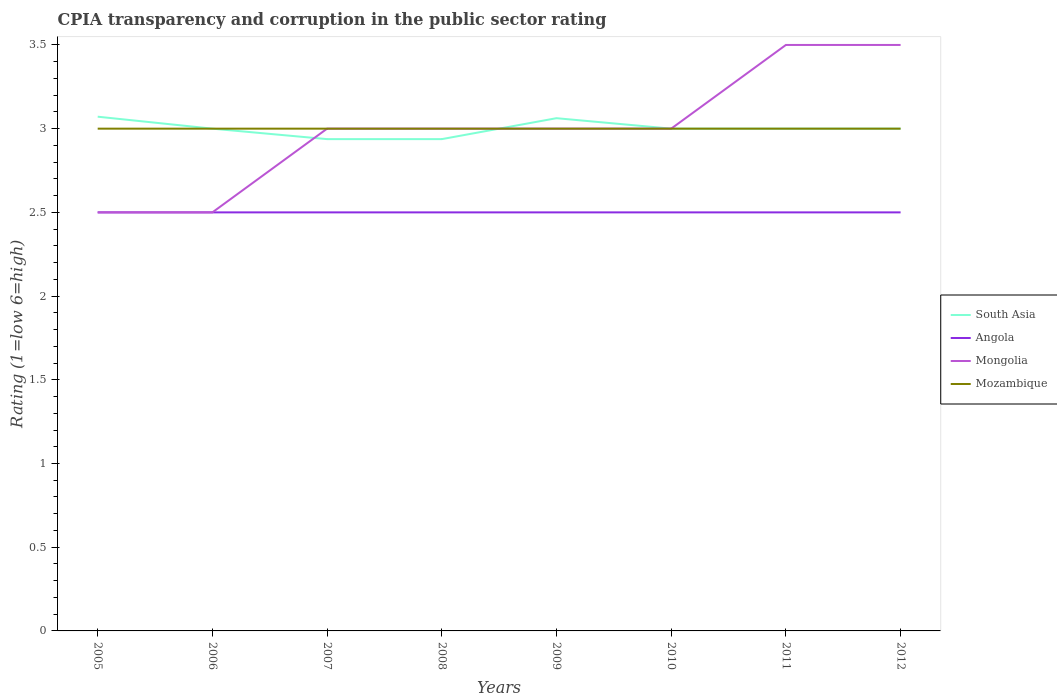How many different coloured lines are there?
Provide a short and direct response. 4. Does the line corresponding to Mongolia intersect with the line corresponding to South Asia?
Offer a very short reply. Yes. Across all years, what is the maximum CPIA rating in Angola?
Your answer should be very brief. 2.5. In which year was the CPIA rating in Angola maximum?
Offer a very short reply. 2005. What is the total CPIA rating in Angola in the graph?
Provide a short and direct response. 0. What is the difference between the highest and the lowest CPIA rating in Mongolia?
Your answer should be very brief. 2. How many years are there in the graph?
Give a very brief answer. 8. Are the values on the major ticks of Y-axis written in scientific E-notation?
Your response must be concise. No. Does the graph contain grids?
Your answer should be very brief. No. Where does the legend appear in the graph?
Provide a short and direct response. Center right. How are the legend labels stacked?
Keep it short and to the point. Vertical. What is the title of the graph?
Offer a very short reply. CPIA transparency and corruption in the public sector rating. Does "Czech Republic" appear as one of the legend labels in the graph?
Provide a short and direct response. No. What is the label or title of the X-axis?
Your answer should be compact. Years. What is the label or title of the Y-axis?
Offer a terse response. Rating (1=low 6=high). What is the Rating (1=low 6=high) in South Asia in 2005?
Keep it short and to the point. 3.07. What is the Rating (1=low 6=high) of Angola in 2005?
Keep it short and to the point. 2.5. What is the Rating (1=low 6=high) in Mozambique in 2005?
Your response must be concise. 3. What is the Rating (1=low 6=high) in South Asia in 2006?
Your answer should be very brief. 3. What is the Rating (1=low 6=high) in Angola in 2006?
Provide a succinct answer. 2.5. What is the Rating (1=low 6=high) of South Asia in 2007?
Keep it short and to the point. 2.94. What is the Rating (1=low 6=high) in Angola in 2007?
Give a very brief answer. 2.5. What is the Rating (1=low 6=high) of Mongolia in 2007?
Keep it short and to the point. 3. What is the Rating (1=low 6=high) of South Asia in 2008?
Provide a short and direct response. 2.94. What is the Rating (1=low 6=high) of Angola in 2008?
Give a very brief answer. 2.5. What is the Rating (1=low 6=high) in South Asia in 2009?
Ensure brevity in your answer.  3.06. What is the Rating (1=low 6=high) in Angola in 2009?
Your answer should be compact. 2.5. What is the Rating (1=low 6=high) in Mongolia in 2009?
Offer a very short reply. 3. What is the Rating (1=low 6=high) in Mongolia in 2011?
Your answer should be very brief. 3.5. What is the Rating (1=low 6=high) in Mozambique in 2011?
Keep it short and to the point. 3. What is the Rating (1=low 6=high) in South Asia in 2012?
Make the answer very short. 3. What is the Rating (1=low 6=high) in Angola in 2012?
Give a very brief answer. 2.5. What is the Rating (1=low 6=high) in Mongolia in 2012?
Your response must be concise. 3.5. Across all years, what is the maximum Rating (1=low 6=high) in South Asia?
Make the answer very short. 3.07. Across all years, what is the maximum Rating (1=low 6=high) in Angola?
Provide a short and direct response. 2.5. Across all years, what is the minimum Rating (1=low 6=high) of South Asia?
Your answer should be very brief. 2.94. Across all years, what is the minimum Rating (1=low 6=high) of Mozambique?
Your response must be concise. 3. What is the total Rating (1=low 6=high) in South Asia in the graph?
Give a very brief answer. 24.01. What is the difference between the Rating (1=low 6=high) in South Asia in 2005 and that in 2006?
Provide a succinct answer. 0.07. What is the difference between the Rating (1=low 6=high) of South Asia in 2005 and that in 2007?
Offer a very short reply. 0.13. What is the difference between the Rating (1=low 6=high) in Angola in 2005 and that in 2007?
Keep it short and to the point. 0. What is the difference between the Rating (1=low 6=high) in South Asia in 2005 and that in 2008?
Offer a terse response. 0.13. What is the difference between the Rating (1=low 6=high) of Angola in 2005 and that in 2008?
Provide a short and direct response. 0. What is the difference between the Rating (1=low 6=high) of Mongolia in 2005 and that in 2008?
Your answer should be compact. -0.5. What is the difference between the Rating (1=low 6=high) in Mozambique in 2005 and that in 2008?
Keep it short and to the point. 0. What is the difference between the Rating (1=low 6=high) of South Asia in 2005 and that in 2009?
Keep it short and to the point. 0.01. What is the difference between the Rating (1=low 6=high) in Angola in 2005 and that in 2009?
Your answer should be compact. 0. What is the difference between the Rating (1=low 6=high) in South Asia in 2005 and that in 2010?
Keep it short and to the point. 0.07. What is the difference between the Rating (1=low 6=high) in Mongolia in 2005 and that in 2010?
Make the answer very short. -0.5. What is the difference between the Rating (1=low 6=high) of Mozambique in 2005 and that in 2010?
Ensure brevity in your answer.  0. What is the difference between the Rating (1=low 6=high) of South Asia in 2005 and that in 2011?
Ensure brevity in your answer.  0.07. What is the difference between the Rating (1=low 6=high) in Angola in 2005 and that in 2011?
Ensure brevity in your answer.  0. What is the difference between the Rating (1=low 6=high) of South Asia in 2005 and that in 2012?
Keep it short and to the point. 0.07. What is the difference between the Rating (1=low 6=high) of Angola in 2005 and that in 2012?
Provide a short and direct response. 0. What is the difference between the Rating (1=low 6=high) in Mongolia in 2005 and that in 2012?
Keep it short and to the point. -1. What is the difference between the Rating (1=low 6=high) in Mozambique in 2005 and that in 2012?
Give a very brief answer. 0. What is the difference between the Rating (1=low 6=high) of South Asia in 2006 and that in 2007?
Offer a terse response. 0.06. What is the difference between the Rating (1=low 6=high) in Mongolia in 2006 and that in 2007?
Offer a very short reply. -0.5. What is the difference between the Rating (1=low 6=high) of Mozambique in 2006 and that in 2007?
Give a very brief answer. 0. What is the difference between the Rating (1=low 6=high) in South Asia in 2006 and that in 2008?
Your response must be concise. 0.06. What is the difference between the Rating (1=low 6=high) in Angola in 2006 and that in 2008?
Keep it short and to the point. 0. What is the difference between the Rating (1=low 6=high) in Mongolia in 2006 and that in 2008?
Offer a terse response. -0.5. What is the difference between the Rating (1=low 6=high) in Mozambique in 2006 and that in 2008?
Provide a succinct answer. 0. What is the difference between the Rating (1=low 6=high) of South Asia in 2006 and that in 2009?
Provide a succinct answer. -0.06. What is the difference between the Rating (1=low 6=high) in Mozambique in 2006 and that in 2009?
Offer a very short reply. 0. What is the difference between the Rating (1=low 6=high) of South Asia in 2006 and that in 2010?
Give a very brief answer. 0. What is the difference between the Rating (1=low 6=high) of Angola in 2006 and that in 2010?
Provide a short and direct response. 0. What is the difference between the Rating (1=low 6=high) of Mozambique in 2006 and that in 2010?
Offer a very short reply. 0. What is the difference between the Rating (1=low 6=high) of Angola in 2006 and that in 2011?
Provide a short and direct response. 0. What is the difference between the Rating (1=low 6=high) of Mongolia in 2006 and that in 2011?
Provide a succinct answer. -1. What is the difference between the Rating (1=low 6=high) in South Asia in 2007 and that in 2008?
Your answer should be compact. 0. What is the difference between the Rating (1=low 6=high) in South Asia in 2007 and that in 2009?
Keep it short and to the point. -0.12. What is the difference between the Rating (1=low 6=high) in Mozambique in 2007 and that in 2009?
Give a very brief answer. 0. What is the difference between the Rating (1=low 6=high) in South Asia in 2007 and that in 2010?
Ensure brevity in your answer.  -0.06. What is the difference between the Rating (1=low 6=high) of Angola in 2007 and that in 2010?
Ensure brevity in your answer.  0. What is the difference between the Rating (1=low 6=high) in Mongolia in 2007 and that in 2010?
Give a very brief answer. 0. What is the difference between the Rating (1=low 6=high) of South Asia in 2007 and that in 2011?
Offer a very short reply. -0.06. What is the difference between the Rating (1=low 6=high) in South Asia in 2007 and that in 2012?
Provide a succinct answer. -0.06. What is the difference between the Rating (1=low 6=high) in Mongolia in 2007 and that in 2012?
Your answer should be very brief. -0.5. What is the difference between the Rating (1=low 6=high) of South Asia in 2008 and that in 2009?
Offer a very short reply. -0.12. What is the difference between the Rating (1=low 6=high) in Angola in 2008 and that in 2009?
Your answer should be very brief. 0. What is the difference between the Rating (1=low 6=high) in Mozambique in 2008 and that in 2009?
Offer a very short reply. 0. What is the difference between the Rating (1=low 6=high) in South Asia in 2008 and that in 2010?
Make the answer very short. -0.06. What is the difference between the Rating (1=low 6=high) in Angola in 2008 and that in 2010?
Provide a succinct answer. 0. What is the difference between the Rating (1=low 6=high) in Mongolia in 2008 and that in 2010?
Make the answer very short. 0. What is the difference between the Rating (1=low 6=high) in South Asia in 2008 and that in 2011?
Ensure brevity in your answer.  -0.06. What is the difference between the Rating (1=low 6=high) in Mongolia in 2008 and that in 2011?
Your answer should be very brief. -0.5. What is the difference between the Rating (1=low 6=high) in Mozambique in 2008 and that in 2011?
Give a very brief answer. 0. What is the difference between the Rating (1=low 6=high) in South Asia in 2008 and that in 2012?
Your answer should be compact. -0.06. What is the difference between the Rating (1=low 6=high) in Mozambique in 2008 and that in 2012?
Make the answer very short. 0. What is the difference between the Rating (1=low 6=high) in South Asia in 2009 and that in 2010?
Offer a very short reply. 0.06. What is the difference between the Rating (1=low 6=high) in Angola in 2009 and that in 2010?
Your answer should be very brief. 0. What is the difference between the Rating (1=low 6=high) in Mozambique in 2009 and that in 2010?
Offer a terse response. 0. What is the difference between the Rating (1=low 6=high) of South Asia in 2009 and that in 2011?
Offer a very short reply. 0.06. What is the difference between the Rating (1=low 6=high) in South Asia in 2009 and that in 2012?
Your response must be concise. 0.06. What is the difference between the Rating (1=low 6=high) in Angola in 2009 and that in 2012?
Your response must be concise. 0. What is the difference between the Rating (1=low 6=high) in Mongolia in 2009 and that in 2012?
Your response must be concise. -0.5. What is the difference between the Rating (1=low 6=high) in Mozambique in 2009 and that in 2012?
Provide a short and direct response. 0. What is the difference between the Rating (1=low 6=high) in Angola in 2010 and that in 2011?
Offer a very short reply. 0. What is the difference between the Rating (1=low 6=high) in South Asia in 2011 and that in 2012?
Make the answer very short. 0. What is the difference between the Rating (1=low 6=high) of South Asia in 2005 and the Rating (1=low 6=high) of Angola in 2006?
Make the answer very short. 0.57. What is the difference between the Rating (1=low 6=high) in South Asia in 2005 and the Rating (1=low 6=high) in Mozambique in 2006?
Make the answer very short. 0.07. What is the difference between the Rating (1=low 6=high) in Angola in 2005 and the Rating (1=low 6=high) in Mozambique in 2006?
Make the answer very short. -0.5. What is the difference between the Rating (1=low 6=high) of South Asia in 2005 and the Rating (1=low 6=high) of Mongolia in 2007?
Offer a terse response. 0.07. What is the difference between the Rating (1=low 6=high) in South Asia in 2005 and the Rating (1=low 6=high) in Mozambique in 2007?
Keep it short and to the point. 0.07. What is the difference between the Rating (1=low 6=high) in Angola in 2005 and the Rating (1=low 6=high) in Mongolia in 2007?
Ensure brevity in your answer.  -0.5. What is the difference between the Rating (1=low 6=high) in Angola in 2005 and the Rating (1=low 6=high) in Mozambique in 2007?
Ensure brevity in your answer.  -0.5. What is the difference between the Rating (1=low 6=high) in South Asia in 2005 and the Rating (1=low 6=high) in Mongolia in 2008?
Give a very brief answer. 0.07. What is the difference between the Rating (1=low 6=high) in South Asia in 2005 and the Rating (1=low 6=high) in Mozambique in 2008?
Offer a terse response. 0.07. What is the difference between the Rating (1=low 6=high) of South Asia in 2005 and the Rating (1=low 6=high) of Mongolia in 2009?
Provide a succinct answer. 0.07. What is the difference between the Rating (1=low 6=high) of South Asia in 2005 and the Rating (1=low 6=high) of Mozambique in 2009?
Keep it short and to the point. 0.07. What is the difference between the Rating (1=low 6=high) in South Asia in 2005 and the Rating (1=low 6=high) in Mongolia in 2010?
Give a very brief answer. 0.07. What is the difference between the Rating (1=low 6=high) in South Asia in 2005 and the Rating (1=low 6=high) in Mozambique in 2010?
Ensure brevity in your answer.  0.07. What is the difference between the Rating (1=low 6=high) in Angola in 2005 and the Rating (1=low 6=high) in Mozambique in 2010?
Offer a terse response. -0.5. What is the difference between the Rating (1=low 6=high) of Mongolia in 2005 and the Rating (1=low 6=high) of Mozambique in 2010?
Your response must be concise. -0.5. What is the difference between the Rating (1=low 6=high) of South Asia in 2005 and the Rating (1=low 6=high) of Mongolia in 2011?
Ensure brevity in your answer.  -0.43. What is the difference between the Rating (1=low 6=high) in South Asia in 2005 and the Rating (1=low 6=high) in Mozambique in 2011?
Ensure brevity in your answer.  0.07. What is the difference between the Rating (1=low 6=high) of Angola in 2005 and the Rating (1=low 6=high) of Mozambique in 2011?
Make the answer very short. -0.5. What is the difference between the Rating (1=low 6=high) of South Asia in 2005 and the Rating (1=low 6=high) of Mongolia in 2012?
Provide a succinct answer. -0.43. What is the difference between the Rating (1=low 6=high) of South Asia in 2005 and the Rating (1=low 6=high) of Mozambique in 2012?
Your answer should be compact. 0.07. What is the difference between the Rating (1=low 6=high) in Angola in 2005 and the Rating (1=low 6=high) in Mongolia in 2012?
Offer a very short reply. -1. What is the difference between the Rating (1=low 6=high) in Angola in 2005 and the Rating (1=low 6=high) in Mozambique in 2012?
Your response must be concise. -0.5. What is the difference between the Rating (1=low 6=high) of South Asia in 2006 and the Rating (1=low 6=high) of Angola in 2007?
Provide a short and direct response. 0.5. What is the difference between the Rating (1=low 6=high) in South Asia in 2006 and the Rating (1=low 6=high) in Mongolia in 2007?
Give a very brief answer. 0. What is the difference between the Rating (1=low 6=high) in Angola in 2006 and the Rating (1=low 6=high) in Mongolia in 2007?
Provide a succinct answer. -0.5. What is the difference between the Rating (1=low 6=high) in South Asia in 2006 and the Rating (1=low 6=high) in Angola in 2008?
Your answer should be very brief. 0.5. What is the difference between the Rating (1=low 6=high) in Mongolia in 2006 and the Rating (1=low 6=high) in Mozambique in 2008?
Provide a succinct answer. -0.5. What is the difference between the Rating (1=low 6=high) of Angola in 2006 and the Rating (1=low 6=high) of Mongolia in 2009?
Provide a short and direct response. -0.5. What is the difference between the Rating (1=low 6=high) in Mongolia in 2006 and the Rating (1=low 6=high) in Mozambique in 2009?
Your response must be concise. -0.5. What is the difference between the Rating (1=low 6=high) of Angola in 2006 and the Rating (1=low 6=high) of Mozambique in 2010?
Give a very brief answer. -0.5. What is the difference between the Rating (1=low 6=high) in Mongolia in 2006 and the Rating (1=low 6=high) in Mozambique in 2010?
Offer a very short reply. -0.5. What is the difference between the Rating (1=low 6=high) of South Asia in 2006 and the Rating (1=low 6=high) of Angola in 2011?
Give a very brief answer. 0.5. What is the difference between the Rating (1=low 6=high) in South Asia in 2006 and the Rating (1=low 6=high) in Mongolia in 2011?
Your answer should be compact. -0.5. What is the difference between the Rating (1=low 6=high) in South Asia in 2006 and the Rating (1=low 6=high) in Mozambique in 2011?
Provide a succinct answer. 0. What is the difference between the Rating (1=low 6=high) of Angola in 2006 and the Rating (1=low 6=high) of Mozambique in 2011?
Offer a very short reply. -0.5. What is the difference between the Rating (1=low 6=high) in Mongolia in 2006 and the Rating (1=low 6=high) in Mozambique in 2011?
Give a very brief answer. -0.5. What is the difference between the Rating (1=low 6=high) of South Asia in 2006 and the Rating (1=low 6=high) of Angola in 2012?
Make the answer very short. 0.5. What is the difference between the Rating (1=low 6=high) in South Asia in 2006 and the Rating (1=low 6=high) in Mongolia in 2012?
Give a very brief answer. -0.5. What is the difference between the Rating (1=low 6=high) of Angola in 2006 and the Rating (1=low 6=high) of Mongolia in 2012?
Provide a short and direct response. -1. What is the difference between the Rating (1=low 6=high) in Mongolia in 2006 and the Rating (1=low 6=high) in Mozambique in 2012?
Keep it short and to the point. -0.5. What is the difference between the Rating (1=low 6=high) of South Asia in 2007 and the Rating (1=low 6=high) of Angola in 2008?
Offer a terse response. 0.44. What is the difference between the Rating (1=low 6=high) of South Asia in 2007 and the Rating (1=low 6=high) of Mongolia in 2008?
Provide a short and direct response. -0.06. What is the difference between the Rating (1=low 6=high) in South Asia in 2007 and the Rating (1=low 6=high) in Mozambique in 2008?
Keep it short and to the point. -0.06. What is the difference between the Rating (1=low 6=high) in South Asia in 2007 and the Rating (1=low 6=high) in Angola in 2009?
Give a very brief answer. 0.44. What is the difference between the Rating (1=low 6=high) in South Asia in 2007 and the Rating (1=low 6=high) in Mongolia in 2009?
Provide a short and direct response. -0.06. What is the difference between the Rating (1=low 6=high) of South Asia in 2007 and the Rating (1=low 6=high) of Mozambique in 2009?
Ensure brevity in your answer.  -0.06. What is the difference between the Rating (1=low 6=high) in Angola in 2007 and the Rating (1=low 6=high) in Mongolia in 2009?
Ensure brevity in your answer.  -0.5. What is the difference between the Rating (1=low 6=high) in Mongolia in 2007 and the Rating (1=low 6=high) in Mozambique in 2009?
Give a very brief answer. 0. What is the difference between the Rating (1=low 6=high) in South Asia in 2007 and the Rating (1=low 6=high) in Angola in 2010?
Make the answer very short. 0.44. What is the difference between the Rating (1=low 6=high) of South Asia in 2007 and the Rating (1=low 6=high) of Mongolia in 2010?
Ensure brevity in your answer.  -0.06. What is the difference between the Rating (1=low 6=high) in South Asia in 2007 and the Rating (1=low 6=high) in Mozambique in 2010?
Offer a terse response. -0.06. What is the difference between the Rating (1=low 6=high) of Angola in 2007 and the Rating (1=low 6=high) of Mozambique in 2010?
Provide a short and direct response. -0.5. What is the difference between the Rating (1=low 6=high) in South Asia in 2007 and the Rating (1=low 6=high) in Angola in 2011?
Your answer should be very brief. 0.44. What is the difference between the Rating (1=low 6=high) in South Asia in 2007 and the Rating (1=low 6=high) in Mongolia in 2011?
Keep it short and to the point. -0.56. What is the difference between the Rating (1=low 6=high) of South Asia in 2007 and the Rating (1=low 6=high) of Mozambique in 2011?
Keep it short and to the point. -0.06. What is the difference between the Rating (1=low 6=high) of Angola in 2007 and the Rating (1=low 6=high) of Mongolia in 2011?
Provide a succinct answer. -1. What is the difference between the Rating (1=low 6=high) in Angola in 2007 and the Rating (1=low 6=high) in Mozambique in 2011?
Make the answer very short. -0.5. What is the difference between the Rating (1=low 6=high) in Mongolia in 2007 and the Rating (1=low 6=high) in Mozambique in 2011?
Make the answer very short. 0. What is the difference between the Rating (1=low 6=high) in South Asia in 2007 and the Rating (1=low 6=high) in Angola in 2012?
Make the answer very short. 0.44. What is the difference between the Rating (1=low 6=high) in South Asia in 2007 and the Rating (1=low 6=high) in Mongolia in 2012?
Your response must be concise. -0.56. What is the difference between the Rating (1=low 6=high) of South Asia in 2007 and the Rating (1=low 6=high) of Mozambique in 2012?
Your answer should be very brief. -0.06. What is the difference between the Rating (1=low 6=high) in Angola in 2007 and the Rating (1=low 6=high) in Mongolia in 2012?
Your answer should be very brief. -1. What is the difference between the Rating (1=low 6=high) of Angola in 2007 and the Rating (1=low 6=high) of Mozambique in 2012?
Your response must be concise. -0.5. What is the difference between the Rating (1=low 6=high) in South Asia in 2008 and the Rating (1=low 6=high) in Angola in 2009?
Your response must be concise. 0.44. What is the difference between the Rating (1=low 6=high) in South Asia in 2008 and the Rating (1=low 6=high) in Mongolia in 2009?
Provide a short and direct response. -0.06. What is the difference between the Rating (1=low 6=high) in South Asia in 2008 and the Rating (1=low 6=high) in Mozambique in 2009?
Make the answer very short. -0.06. What is the difference between the Rating (1=low 6=high) in Angola in 2008 and the Rating (1=low 6=high) in Mongolia in 2009?
Provide a succinct answer. -0.5. What is the difference between the Rating (1=low 6=high) in Angola in 2008 and the Rating (1=low 6=high) in Mozambique in 2009?
Offer a terse response. -0.5. What is the difference between the Rating (1=low 6=high) in South Asia in 2008 and the Rating (1=low 6=high) in Angola in 2010?
Offer a terse response. 0.44. What is the difference between the Rating (1=low 6=high) of South Asia in 2008 and the Rating (1=low 6=high) of Mongolia in 2010?
Offer a very short reply. -0.06. What is the difference between the Rating (1=low 6=high) in South Asia in 2008 and the Rating (1=low 6=high) in Mozambique in 2010?
Provide a succinct answer. -0.06. What is the difference between the Rating (1=low 6=high) of Angola in 2008 and the Rating (1=low 6=high) of Mongolia in 2010?
Offer a very short reply. -0.5. What is the difference between the Rating (1=low 6=high) of Angola in 2008 and the Rating (1=low 6=high) of Mozambique in 2010?
Offer a terse response. -0.5. What is the difference between the Rating (1=low 6=high) in South Asia in 2008 and the Rating (1=low 6=high) in Angola in 2011?
Keep it short and to the point. 0.44. What is the difference between the Rating (1=low 6=high) in South Asia in 2008 and the Rating (1=low 6=high) in Mongolia in 2011?
Give a very brief answer. -0.56. What is the difference between the Rating (1=low 6=high) in South Asia in 2008 and the Rating (1=low 6=high) in Mozambique in 2011?
Your response must be concise. -0.06. What is the difference between the Rating (1=low 6=high) in Angola in 2008 and the Rating (1=low 6=high) in Mongolia in 2011?
Your answer should be compact. -1. What is the difference between the Rating (1=low 6=high) of Angola in 2008 and the Rating (1=low 6=high) of Mozambique in 2011?
Provide a short and direct response. -0.5. What is the difference between the Rating (1=low 6=high) of Mongolia in 2008 and the Rating (1=low 6=high) of Mozambique in 2011?
Provide a short and direct response. 0. What is the difference between the Rating (1=low 6=high) of South Asia in 2008 and the Rating (1=low 6=high) of Angola in 2012?
Ensure brevity in your answer.  0.44. What is the difference between the Rating (1=low 6=high) of South Asia in 2008 and the Rating (1=low 6=high) of Mongolia in 2012?
Your response must be concise. -0.56. What is the difference between the Rating (1=low 6=high) in South Asia in 2008 and the Rating (1=low 6=high) in Mozambique in 2012?
Provide a short and direct response. -0.06. What is the difference between the Rating (1=low 6=high) of Angola in 2008 and the Rating (1=low 6=high) of Mongolia in 2012?
Give a very brief answer. -1. What is the difference between the Rating (1=low 6=high) of Angola in 2008 and the Rating (1=low 6=high) of Mozambique in 2012?
Your answer should be very brief. -0.5. What is the difference between the Rating (1=low 6=high) in Mongolia in 2008 and the Rating (1=low 6=high) in Mozambique in 2012?
Provide a short and direct response. 0. What is the difference between the Rating (1=low 6=high) of South Asia in 2009 and the Rating (1=low 6=high) of Angola in 2010?
Make the answer very short. 0.56. What is the difference between the Rating (1=low 6=high) of South Asia in 2009 and the Rating (1=low 6=high) of Mongolia in 2010?
Give a very brief answer. 0.06. What is the difference between the Rating (1=low 6=high) of South Asia in 2009 and the Rating (1=low 6=high) of Mozambique in 2010?
Keep it short and to the point. 0.06. What is the difference between the Rating (1=low 6=high) of Angola in 2009 and the Rating (1=low 6=high) of Mozambique in 2010?
Keep it short and to the point. -0.5. What is the difference between the Rating (1=low 6=high) of Mongolia in 2009 and the Rating (1=low 6=high) of Mozambique in 2010?
Your answer should be compact. 0. What is the difference between the Rating (1=low 6=high) of South Asia in 2009 and the Rating (1=low 6=high) of Angola in 2011?
Provide a succinct answer. 0.56. What is the difference between the Rating (1=low 6=high) of South Asia in 2009 and the Rating (1=low 6=high) of Mongolia in 2011?
Keep it short and to the point. -0.44. What is the difference between the Rating (1=low 6=high) in South Asia in 2009 and the Rating (1=low 6=high) in Mozambique in 2011?
Offer a very short reply. 0.06. What is the difference between the Rating (1=low 6=high) in Angola in 2009 and the Rating (1=low 6=high) in Mongolia in 2011?
Give a very brief answer. -1. What is the difference between the Rating (1=low 6=high) in Angola in 2009 and the Rating (1=low 6=high) in Mozambique in 2011?
Offer a very short reply. -0.5. What is the difference between the Rating (1=low 6=high) of South Asia in 2009 and the Rating (1=low 6=high) of Angola in 2012?
Offer a very short reply. 0.56. What is the difference between the Rating (1=low 6=high) in South Asia in 2009 and the Rating (1=low 6=high) in Mongolia in 2012?
Keep it short and to the point. -0.44. What is the difference between the Rating (1=low 6=high) in South Asia in 2009 and the Rating (1=low 6=high) in Mozambique in 2012?
Offer a very short reply. 0.06. What is the difference between the Rating (1=low 6=high) in South Asia in 2010 and the Rating (1=low 6=high) in Angola in 2011?
Your answer should be compact. 0.5. What is the difference between the Rating (1=low 6=high) of Angola in 2010 and the Rating (1=low 6=high) of Mongolia in 2011?
Provide a short and direct response. -1. What is the difference between the Rating (1=low 6=high) of Angola in 2010 and the Rating (1=low 6=high) of Mozambique in 2011?
Offer a very short reply. -0.5. What is the difference between the Rating (1=low 6=high) in Mongolia in 2010 and the Rating (1=low 6=high) in Mozambique in 2011?
Offer a very short reply. 0. What is the difference between the Rating (1=low 6=high) in South Asia in 2010 and the Rating (1=low 6=high) in Angola in 2012?
Provide a succinct answer. 0.5. What is the difference between the Rating (1=low 6=high) in South Asia in 2010 and the Rating (1=low 6=high) in Mongolia in 2012?
Provide a short and direct response. -0.5. What is the difference between the Rating (1=low 6=high) in Angola in 2010 and the Rating (1=low 6=high) in Mongolia in 2012?
Your answer should be compact. -1. What is the difference between the Rating (1=low 6=high) of Mongolia in 2010 and the Rating (1=low 6=high) of Mozambique in 2012?
Offer a very short reply. 0. What is the difference between the Rating (1=low 6=high) of South Asia in 2011 and the Rating (1=low 6=high) of Mongolia in 2012?
Provide a succinct answer. -0.5. What is the difference between the Rating (1=low 6=high) in South Asia in 2011 and the Rating (1=low 6=high) in Mozambique in 2012?
Make the answer very short. 0. What is the difference between the Rating (1=low 6=high) of Angola in 2011 and the Rating (1=low 6=high) of Mozambique in 2012?
Provide a succinct answer. -0.5. What is the average Rating (1=low 6=high) of South Asia per year?
Offer a very short reply. 3. What is the average Rating (1=low 6=high) of Angola per year?
Give a very brief answer. 2.5. What is the average Rating (1=low 6=high) in Mozambique per year?
Offer a terse response. 3. In the year 2005, what is the difference between the Rating (1=low 6=high) of South Asia and Rating (1=low 6=high) of Angola?
Your answer should be very brief. 0.57. In the year 2005, what is the difference between the Rating (1=low 6=high) of South Asia and Rating (1=low 6=high) of Mozambique?
Keep it short and to the point. 0.07. In the year 2005, what is the difference between the Rating (1=low 6=high) in Angola and Rating (1=low 6=high) in Mozambique?
Offer a very short reply. -0.5. In the year 2006, what is the difference between the Rating (1=low 6=high) of South Asia and Rating (1=low 6=high) of Mongolia?
Offer a very short reply. 0.5. In the year 2006, what is the difference between the Rating (1=low 6=high) in South Asia and Rating (1=low 6=high) in Mozambique?
Make the answer very short. 0. In the year 2006, what is the difference between the Rating (1=low 6=high) in Angola and Rating (1=low 6=high) in Mozambique?
Keep it short and to the point. -0.5. In the year 2007, what is the difference between the Rating (1=low 6=high) of South Asia and Rating (1=low 6=high) of Angola?
Your answer should be compact. 0.44. In the year 2007, what is the difference between the Rating (1=low 6=high) of South Asia and Rating (1=low 6=high) of Mongolia?
Ensure brevity in your answer.  -0.06. In the year 2007, what is the difference between the Rating (1=low 6=high) of South Asia and Rating (1=low 6=high) of Mozambique?
Provide a short and direct response. -0.06. In the year 2007, what is the difference between the Rating (1=low 6=high) of Angola and Rating (1=low 6=high) of Mongolia?
Provide a succinct answer. -0.5. In the year 2007, what is the difference between the Rating (1=low 6=high) of Angola and Rating (1=low 6=high) of Mozambique?
Provide a succinct answer. -0.5. In the year 2008, what is the difference between the Rating (1=low 6=high) of South Asia and Rating (1=low 6=high) of Angola?
Your answer should be compact. 0.44. In the year 2008, what is the difference between the Rating (1=low 6=high) in South Asia and Rating (1=low 6=high) in Mongolia?
Your response must be concise. -0.06. In the year 2008, what is the difference between the Rating (1=low 6=high) in South Asia and Rating (1=low 6=high) in Mozambique?
Your answer should be compact. -0.06. In the year 2008, what is the difference between the Rating (1=low 6=high) in Angola and Rating (1=low 6=high) in Mozambique?
Offer a terse response. -0.5. In the year 2009, what is the difference between the Rating (1=low 6=high) in South Asia and Rating (1=low 6=high) in Angola?
Offer a very short reply. 0.56. In the year 2009, what is the difference between the Rating (1=low 6=high) of South Asia and Rating (1=low 6=high) of Mongolia?
Your answer should be very brief. 0.06. In the year 2009, what is the difference between the Rating (1=low 6=high) in South Asia and Rating (1=low 6=high) in Mozambique?
Your answer should be very brief. 0.06. In the year 2009, what is the difference between the Rating (1=low 6=high) of Angola and Rating (1=low 6=high) of Mongolia?
Give a very brief answer. -0.5. In the year 2009, what is the difference between the Rating (1=low 6=high) in Angola and Rating (1=low 6=high) in Mozambique?
Your answer should be compact. -0.5. In the year 2009, what is the difference between the Rating (1=low 6=high) in Mongolia and Rating (1=low 6=high) in Mozambique?
Ensure brevity in your answer.  0. In the year 2010, what is the difference between the Rating (1=low 6=high) of South Asia and Rating (1=low 6=high) of Mozambique?
Keep it short and to the point. 0. In the year 2010, what is the difference between the Rating (1=low 6=high) in Angola and Rating (1=low 6=high) in Mongolia?
Give a very brief answer. -0.5. In the year 2010, what is the difference between the Rating (1=low 6=high) of Mongolia and Rating (1=low 6=high) of Mozambique?
Offer a terse response. 0. In the year 2011, what is the difference between the Rating (1=low 6=high) in South Asia and Rating (1=low 6=high) in Angola?
Offer a terse response. 0.5. In the year 2011, what is the difference between the Rating (1=low 6=high) of South Asia and Rating (1=low 6=high) of Mozambique?
Offer a very short reply. 0. In the year 2012, what is the difference between the Rating (1=low 6=high) in South Asia and Rating (1=low 6=high) in Mongolia?
Give a very brief answer. -0.5. In the year 2012, what is the difference between the Rating (1=low 6=high) in South Asia and Rating (1=low 6=high) in Mozambique?
Give a very brief answer. 0. In the year 2012, what is the difference between the Rating (1=low 6=high) of Mongolia and Rating (1=low 6=high) of Mozambique?
Your answer should be very brief. 0.5. What is the ratio of the Rating (1=low 6=high) of South Asia in 2005 to that in 2006?
Make the answer very short. 1.02. What is the ratio of the Rating (1=low 6=high) of Angola in 2005 to that in 2006?
Make the answer very short. 1. What is the ratio of the Rating (1=low 6=high) of Mongolia in 2005 to that in 2006?
Offer a terse response. 1. What is the ratio of the Rating (1=low 6=high) in Mozambique in 2005 to that in 2006?
Provide a succinct answer. 1. What is the ratio of the Rating (1=low 6=high) in South Asia in 2005 to that in 2007?
Keep it short and to the point. 1.05. What is the ratio of the Rating (1=low 6=high) of Mongolia in 2005 to that in 2007?
Offer a very short reply. 0.83. What is the ratio of the Rating (1=low 6=high) in Mozambique in 2005 to that in 2007?
Your answer should be compact. 1. What is the ratio of the Rating (1=low 6=high) in South Asia in 2005 to that in 2008?
Your answer should be compact. 1.05. What is the ratio of the Rating (1=low 6=high) in Angola in 2005 to that in 2008?
Ensure brevity in your answer.  1. What is the ratio of the Rating (1=low 6=high) in Mozambique in 2005 to that in 2008?
Provide a short and direct response. 1. What is the ratio of the Rating (1=low 6=high) in Mongolia in 2005 to that in 2009?
Provide a short and direct response. 0.83. What is the ratio of the Rating (1=low 6=high) of South Asia in 2005 to that in 2010?
Give a very brief answer. 1.02. What is the ratio of the Rating (1=low 6=high) of Mozambique in 2005 to that in 2010?
Provide a succinct answer. 1. What is the ratio of the Rating (1=low 6=high) in South Asia in 2005 to that in 2011?
Your response must be concise. 1.02. What is the ratio of the Rating (1=low 6=high) of Angola in 2005 to that in 2011?
Keep it short and to the point. 1. What is the ratio of the Rating (1=low 6=high) in South Asia in 2005 to that in 2012?
Make the answer very short. 1.02. What is the ratio of the Rating (1=low 6=high) in Angola in 2005 to that in 2012?
Ensure brevity in your answer.  1. What is the ratio of the Rating (1=low 6=high) in Mozambique in 2005 to that in 2012?
Keep it short and to the point. 1. What is the ratio of the Rating (1=low 6=high) of South Asia in 2006 to that in 2007?
Make the answer very short. 1.02. What is the ratio of the Rating (1=low 6=high) of Mozambique in 2006 to that in 2007?
Offer a very short reply. 1. What is the ratio of the Rating (1=low 6=high) in South Asia in 2006 to that in 2008?
Offer a very short reply. 1.02. What is the ratio of the Rating (1=low 6=high) in Mongolia in 2006 to that in 2008?
Provide a succinct answer. 0.83. What is the ratio of the Rating (1=low 6=high) in Mozambique in 2006 to that in 2008?
Offer a very short reply. 1. What is the ratio of the Rating (1=low 6=high) in South Asia in 2006 to that in 2009?
Give a very brief answer. 0.98. What is the ratio of the Rating (1=low 6=high) of Mongolia in 2006 to that in 2009?
Provide a short and direct response. 0.83. What is the ratio of the Rating (1=low 6=high) of Mozambique in 2006 to that in 2009?
Offer a terse response. 1. What is the ratio of the Rating (1=low 6=high) in South Asia in 2006 to that in 2011?
Your answer should be compact. 1. What is the ratio of the Rating (1=low 6=high) in Mongolia in 2006 to that in 2011?
Your response must be concise. 0.71. What is the ratio of the Rating (1=low 6=high) of Angola in 2006 to that in 2012?
Your response must be concise. 1. What is the ratio of the Rating (1=low 6=high) in Mongolia in 2006 to that in 2012?
Provide a short and direct response. 0.71. What is the ratio of the Rating (1=low 6=high) of Mozambique in 2006 to that in 2012?
Your answer should be compact. 1. What is the ratio of the Rating (1=low 6=high) of Angola in 2007 to that in 2008?
Keep it short and to the point. 1. What is the ratio of the Rating (1=low 6=high) of Mozambique in 2007 to that in 2008?
Your answer should be compact. 1. What is the ratio of the Rating (1=low 6=high) in South Asia in 2007 to that in 2009?
Ensure brevity in your answer.  0.96. What is the ratio of the Rating (1=low 6=high) in Mongolia in 2007 to that in 2009?
Provide a succinct answer. 1. What is the ratio of the Rating (1=low 6=high) of Mozambique in 2007 to that in 2009?
Provide a succinct answer. 1. What is the ratio of the Rating (1=low 6=high) of South Asia in 2007 to that in 2010?
Provide a succinct answer. 0.98. What is the ratio of the Rating (1=low 6=high) of Angola in 2007 to that in 2010?
Make the answer very short. 1. What is the ratio of the Rating (1=low 6=high) in Mongolia in 2007 to that in 2010?
Offer a terse response. 1. What is the ratio of the Rating (1=low 6=high) of South Asia in 2007 to that in 2011?
Your answer should be very brief. 0.98. What is the ratio of the Rating (1=low 6=high) of South Asia in 2007 to that in 2012?
Provide a succinct answer. 0.98. What is the ratio of the Rating (1=low 6=high) of Angola in 2007 to that in 2012?
Provide a short and direct response. 1. What is the ratio of the Rating (1=low 6=high) in Mongolia in 2007 to that in 2012?
Offer a very short reply. 0.86. What is the ratio of the Rating (1=low 6=high) of Mozambique in 2007 to that in 2012?
Give a very brief answer. 1. What is the ratio of the Rating (1=low 6=high) of South Asia in 2008 to that in 2009?
Keep it short and to the point. 0.96. What is the ratio of the Rating (1=low 6=high) of South Asia in 2008 to that in 2010?
Provide a short and direct response. 0.98. What is the ratio of the Rating (1=low 6=high) in Angola in 2008 to that in 2010?
Your answer should be compact. 1. What is the ratio of the Rating (1=low 6=high) of South Asia in 2008 to that in 2011?
Give a very brief answer. 0.98. What is the ratio of the Rating (1=low 6=high) of Mongolia in 2008 to that in 2011?
Your answer should be very brief. 0.86. What is the ratio of the Rating (1=low 6=high) in South Asia in 2008 to that in 2012?
Ensure brevity in your answer.  0.98. What is the ratio of the Rating (1=low 6=high) of Angola in 2008 to that in 2012?
Your answer should be compact. 1. What is the ratio of the Rating (1=low 6=high) in Mongolia in 2008 to that in 2012?
Your answer should be compact. 0.86. What is the ratio of the Rating (1=low 6=high) of Mozambique in 2008 to that in 2012?
Make the answer very short. 1. What is the ratio of the Rating (1=low 6=high) of South Asia in 2009 to that in 2010?
Make the answer very short. 1.02. What is the ratio of the Rating (1=low 6=high) of Mongolia in 2009 to that in 2010?
Offer a very short reply. 1. What is the ratio of the Rating (1=low 6=high) of Mozambique in 2009 to that in 2010?
Your answer should be compact. 1. What is the ratio of the Rating (1=low 6=high) of South Asia in 2009 to that in 2011?
Your response must be concise. 1.02. What is the ratio of the Rating (1=low 6=high) in Angola in 2009 to that in 2011?
Offer a terse response. 1. What is the ratio of the Rating (1=low 6=high) in Mongolia in 2009 to that in 2011?
Make the answer very short. 0.86. What is the ratio of the Rating (1=low 6=high) in Mozambique in 2009 to that in 2011?
Give a very brief answer. 1. What is the ratio of the Rating (1=low 6=high) in South Asia in 2009 to that in 2012?
Offer a very short reply. 1.02. What is the ratio of the Rating (1=low 6=high) in South Asia in 2010 to that in 2011?
Provide a short and direct response. 1. What is the ratio of the Rating (1=low 6=high) in Mozambique in 2010 to that in 2011?
Ensure brevity in your answer.  1. What is the ratio of the Rating (1=low 6=high) of Mongolia in 2010 to that in 2012?
Offer a terse response. 0.86. What is the ratio of the Rating (1=low 6=high) in Angola in 2011 to that in 2012?
Offer a terse response. 1. What is the difference between the highest and the second highest Rating (1=low 6=high) of South Asia?
Your response must be concise. 0.01. What is the difference between the highest and the second highest Rating (1=low 6=high) in Angola?
Your answer should be very brief. 0. What is the difference between the highest and the second highest Rating (1=low 6=high) of Mongolia?
Keep it short and to the point. 0. What is the difference between the highest and the second highest Rating (1=low 6=high) of Mozambique?
Your answer should be very brief. 0. What is the difference between the highest and the lowest Rating (1=low 6=high) in South Asia?
Give a very brief answer. 0.13. What is the difference between the highest and the lowest Rating (1=low 6=high) in Angola?
Offer a terse response. 0. 